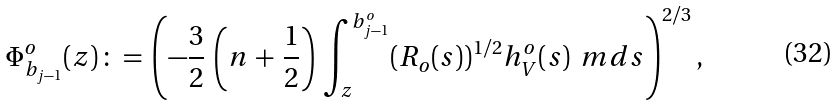Convert formula to latex. <formula><loc_0><loc_0><loc_500><loc_500>\Phi _ { b _ { j - 1 } } ^ { o } ( z ) \, \colon = \, \left ( - \frac { 3 } { 2 } \, \left ( n \, + \, \frac { 1 } { 2 } \right ) \, \int _ { z } ^ { b _ { j - 1 } ^ { o } } ( R _ { o } ( s ) ) ^ { 1 / 2 } h _ { V } ^ { o } ( s ) \, \ m d s \right ) ^ { 2 / 3 } ,</formula> 